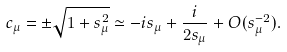<formula> <loc_0><loc_0><loc_500><loc_500>c _ { \mu } = \pm \sqrt { 1 + s _ { \mu } ^ { 2 } } \simeq - i s _ { \mu } + \frac { i } { 2 s _ { \mu } } + O ( s _ { \mu } ^ { - 2 } ) .</formula> 